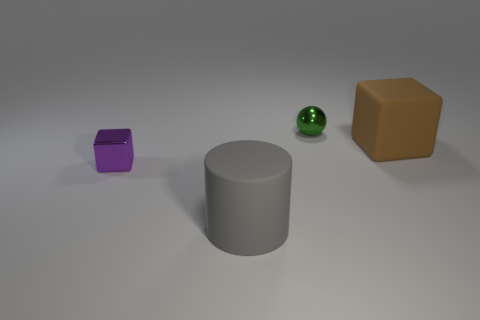Subtract all cyan cylinders. Subtract all green spheres. How many cylinders are left? 1 Add 1 big red cylinders. How many objects exist? 5 Subtract all cylinders. How many objects are left? 3 Add 2 large purple balls. How many large purple balls exist? 2 Subtract 0 cyan balls. How many objects are left? 4 Subtract all large yellow rubber blocks. Subtract all big gray cylinders. How many objects are left? 3 Add 2 large brown things. How many large brown things are left? 3 